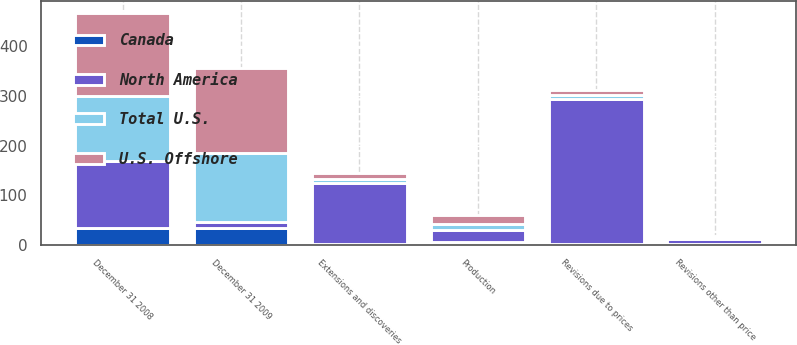Convert chart. <chart><loc_0><loc_0><loc_500><loc_500><stacked_bar_chart><ecel><fcel>December 31 2008<fcel>Revisions due to prices<fcel>Extensions and discoveries<fcel>Production<fcel>December 31 2009<fcel>Revisions other than price<nl><fcel>Total U.S.<fcel>133<fcel>9<fcel>9<fcel>12<fcel>139<fcel>2<nl><fcel>Canada<fcel>34<fcel>2<fcel>2<fcel>5<fcel>33<fcel>2<nl><fcel>U.S. Offshore<fcel>167<fcel>11<fcel>11<fcel>17<fcel>172<fcel>4<nl><fcel>North America<fcel>134<fcel>291<fcel>122<fcel>25<fcel>12<fcel>9<nl></chart> 